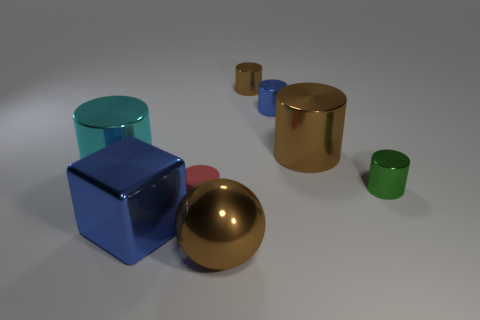Is the color of the large sphere the same as the large metallic cylinder right of the matte thing?
Your answer should be very brief. Yes. What material is the small object on the left side of the big brown shiny object that is in front of the large cylinder that is on the left side of the tiny red matte cylinder?
Your answer should be compact. Rubber. There is a small cylinder that is the same color as the big cube; what material is it?
Offer a very short reply. Metal. Is there any other thing that has the same shape as the large blue shiny object?
Keep it short and to the point. No. There is a large shiny object that is on the right side of the small brown object; is its color the same as the shiny sphere?
Your answer should be compact. Yes. Is the number of metallic objects that are to the right of the small red cylinder less than the number of objects behind the ball?
Your answer should be compact. Yes. What is the size of the cyan object that is the same shape as the small green object?
Provide a succinct answer. Large. How many things are cylinders on the right side of the big brown cylinder or metallic objects behind the big blue thing?
Offer a very short reply. 5. Is the cyan thing the same size as the sphere?
Offer a terse response. Yes. Is the number of small rubber cylinders greater than the number of tiny objects?
Provide a short and direct response. No. 